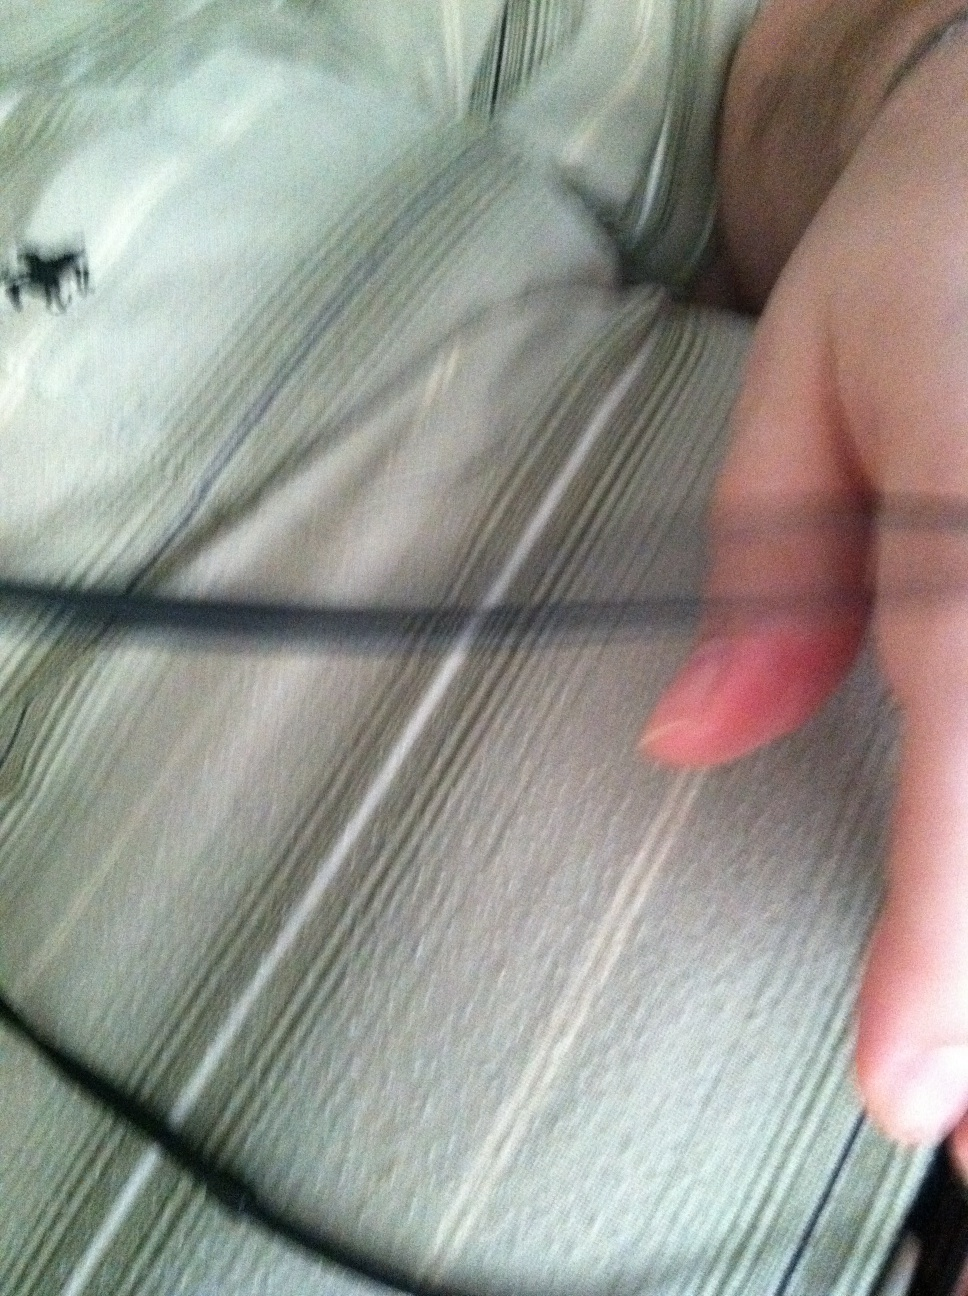What would be an ideal setting or occasion to wear this shirt? This shirt would be ideal for a variety of casual settings such as a weekend brunch, a relaxed office day, or a casual evening out with friends. Its versatile style allows it to be dressed up or down to suit different occasions. 